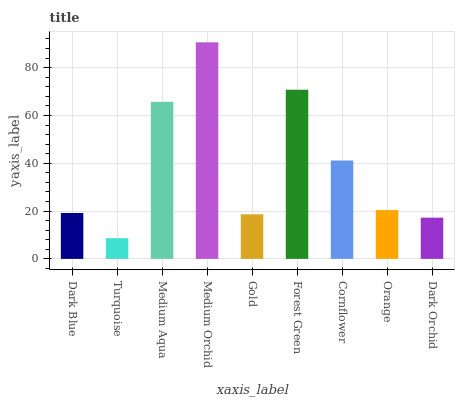Is Turquoise the minimum?
Answer yes or no. Yes. Is Medium Orchid the maximum?
Answer yes or no. Yes. Is Medium Aqua the minimum?
Answer yes or no. No. Is Medium Aqua the maximum?
Answer yes or no. No. Is Medium Aqua greater than Turquoise?
Answer yes or no. Yes. Is Turquoise less than Medium Aqua?
Answer yes or no. Yes. Is Turquoise greater than Medium Aqua?
Answer yes or no. No. Is Medium Aqua less than Turquoise?
Answer yes or no. No. Is Orange the high median?
Answer yes or no. Yes. Is Orange the low median?
Answer yes or no. Yes. Is Cornflower the high median?
Answer yes or no. No. Is Forest Green the low median?
Answer yes or no. No. 